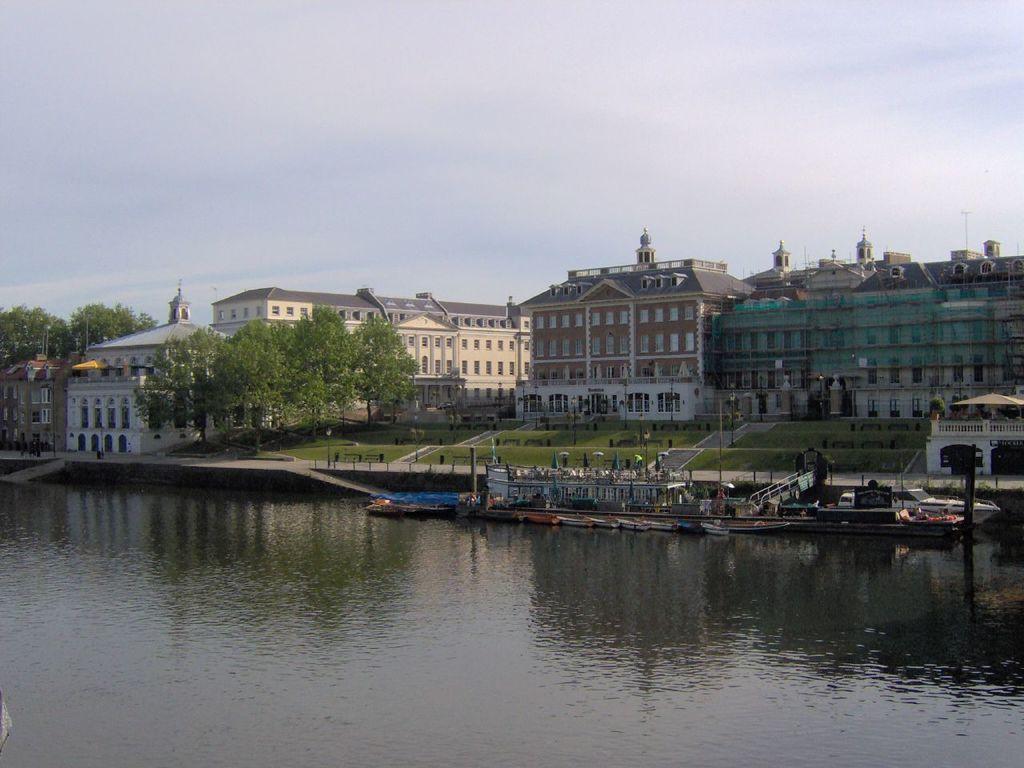Can you describe this image briefly? In this picture we can see boats on water, trees, buildings with windows, grass, poles and in the background we can see the sky with clouds. 